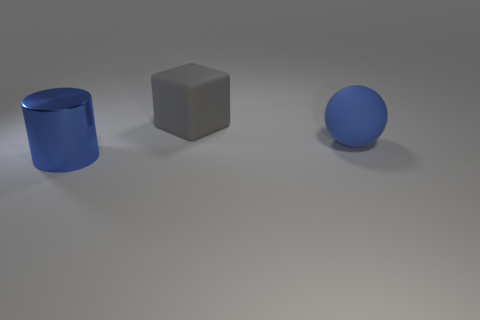Is there any other thing that has the same material as the big blue cylinder?
Your answer should be compact. No. Are there fewer balls in front of the gray cube than objects?
Make the answer very short. Yes. There is a large object left of the rubber thing that is behind the matte thing that is in front of the block; what color is it?
Ensure brevity in your answer.  Blue. What number of matte things are either big cubes or big blue objects?
Ensure brevity in your answer.  2. Are there fewer big gray objects that are left of the matte cube than large objects on the right side of the sphere?
Ensure brevity in your answer.  No. What number of tiny things are cyan matte balls or matte cubes?
Provide a succinct answer. 0. Is the size of the ball the same as the thing on the left side of the gray thing?
Keep it short and to the point. Yes. Is there anything else that has the same shape as the big shiny object?
Offer a very short reply. No. How many big brown matte balls are there?
Offer a very short reply. 0. How many gray things are cylinders or large blocks?
Offer a terse response. 1. 